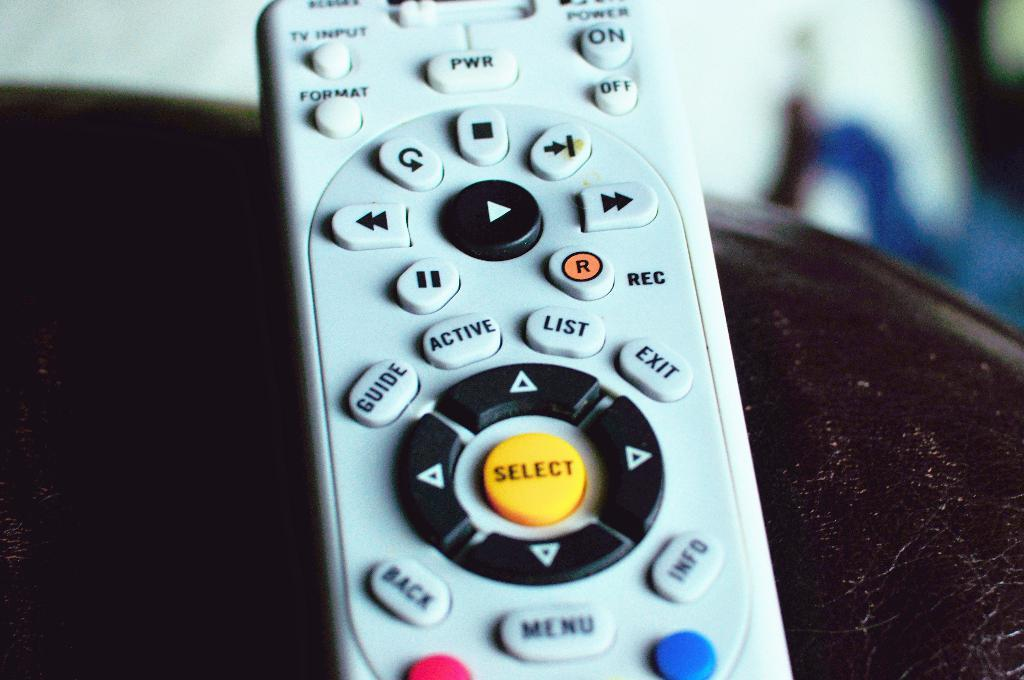What object can be seen on the surface in the image? There is a remote on the surface in the image. Can you describe the background of the image? The background of the image is blurred. What type of cream is being applied to the grandmother in the image? There is no grandmother or cream present in the image. 